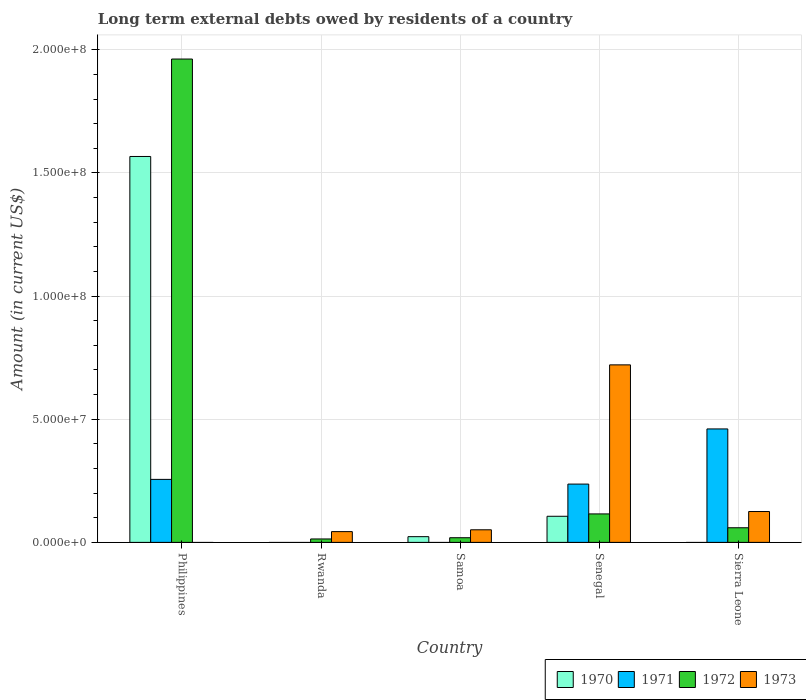How many different coloured bars are there?
Offer a very short reply. 4. Are the number of bars per tick equal to the number of legend labels?
Your answer should be very brief. No. How many bars are there on the 5th tick from the left?
Give a very brief answer. 3. What is the label of the 1st group of bars from the left?
Your response must be concise. Philippines. What is the amount of long-term external debts owed by residents in 1970 in Philippines?
Give a very brief answer. 1.57e+08. Across all countries, what is the maximum amount of long-term external debts owed by residents in 1973?
Provide a short and direct response. 7.21e+07. In which country was the amount of long-term external debts owed by residents in 1971 maximum?
Make the answer very short. Sierra Leone. What is the total amount of long-term external debts owed by residents in 1973 in the graph?
Make the answer very short. 9.41e+07. What is the difference between the amount of long-term external debts owed by residents in 1970 in Philippines and that in Samoa?
Ensure brevity in your answer.  1.54e+08. What is the difference between the amount of long-term external debts owed by residents in 1971 in Sierra Leone and the amount of long-term external debts owed by residents in 1973 in Rwanda?
Your response must be concise. 4.17e+07. What is the average amount of long-term external debts owed by residents in 1972 per country?
Provide a succinct answer. 4.34e+07. What is the difference between the amount of long-term external debts owed by residents of/in 1972 and amount of long-term external debts owed by residents of/in 1971 in Philippines?
Your answer should be very brief. 1.71e+08. In how many countries, is the amount of long-term external debts owed by residents in 1973 greater than 10000000 US$?
Make the answer very short. 2. What is the ratio of the amount of long-term external debts owed by residents in 1970 in Philippines to that in Senegal?
Offer a very short reply. 14.78. Is the amount of long-term external debts owed by residents in 1971 in Philippines less than that in Senegal?
Ensure brevity in your answer.  No. Is the difference between the amount of long-term external debts owed by residents in 1972 in Philippines and Senegal greater than the difference between the amount of long-term external debts owed by residents in 1971 in Philippines and Senegal?
Give a very brief answer. Yes. What is the difference between the highest and the second highest amount of long-term external debts owed by residents in 1972?
Offer a very short reply. 1.90e+08. What is the difference between the highest and the lowest amount of long-term external debts owed by residents in 1970?
Give a very brief answer. 1.57e+08. In how many countries, is the amount of long-term external debts owed by residents in 1970 greater than the average amount of long-term external debts owed by residents in 1970 taken over all countries?
Offer a terse response. 1. Is the sum of the amount of long-term external debts owed by residents in 1973 in Samoa and Sierra Leone greater than the maximum amount of long-term external debts owed by residents in 1970 across all countries?
Offer a terse response. No. Are the values on the major ticks of Y-axis written in scientific E-notation?
Make the answer very short. Yes. Where does the legend appear in the graph?
Provide a succinct answer. Bottom right. How many legend labels are there?
Keep it short and to the point. 4. How are the legend labels stacked?
Offer a very short reply. Horizontal. What is the title of the graph?
Provide a short and direct response. Long term external debts owed by residents of a country. Does "2013" appear as one of the legend labels in the graph?
Your response must be concise. No. What is the label or title of the X-axis?
Your answer should be compact. Country. What is the label or title of the Y-axis?
Provide a short and direct response. Amount (in current US$). What is the Amount (in current US$) of 1970 in Philippines?
Offer a very short reply. 1.57e+08. What is the Amount (in current US$) in 1971 in Philippines?
Offer a terse response. 2.56e+07. What is the Amount (in current US$) in 1972 in Philippines?
Ensure brevity in your answer.  1.96e+08. What is the Amount (in current US$) in 1972 in Rwanda?
Your response must be concise. 1.39e+06. What is the Amount (in current US$) in 1973 in Rwanda?
Your response must be concise. 4.37e+06. What is the Amount (in current US$) of 1970 in Samoa?
Your answer should be compact. 2.32e+06. What is the Amount (in current US$) in 1972 in Samoa?
Provide a succinct answer. 1.89e+06. What is the Amount (in current US$) of 1973 in Samoa?
Provide a succinct answer. 5.11e+06. What is the Amount (in current US$) in 1970 in Senegal?
Provide a succinct answer. 1.06e+07. What is the Amount (in current US$) in 1971 in Senegal?
Your answer should be very brief. 2.37e+07. What is the Amount (in current US$) in 1972 in Senegal?
Make the answer very short. 1.16e+07. What is the Amount (in current US$) of 1973 in Senegal?
Offer a terse response. 7.21e+07. What is the Amount (in current US$) of 1970 in Sierra Leone?
Provide a succinct answer. 0. What is the Amount (in current US$) of 1971 in Sierra Leone?
Your answer should be compact. 4.61e+07. What is the Amount (in current US$) of 1972 in Sierra Leone?
Offer a terse response. 5.94e+06. What is the Amount (in current US$) of 1973 in Sierra Leone?
Offer a terse response. 1.25e+07. Across all countries, what is the maximum Amount (in current US$) of 1970?
Your answer should be very brief. 1.57e+08. Across all countries, what is the maximum Amount (in current US$) in 1971?
Offer a very short reply. 4.61e+07. Across all countries, what is the maximum Amount (in current US$) in 1972?
Provide a short and direct response. 1.96e+08. Across all countries, what is the maximum Amount (in current US$) in 1973?
Your answer should be compact. 7.21e+07. Across all countries, what is the minimum Amount (in current US$) in 1970?
Ensure brevity in your answer.  0. Across all countries, what is the minimum Amount (in current US$) of 1972?
Make the answer very short. 1.39e+06. What is the total Amount (in current US$) of 1970 in the graph?
Offer a very short reply. 1.70e+08. What is the total Amount (in current US$) in 1971 in the graph?
Make the answer very short. 9.53e+07. What is the total Amount (in current US$) in 1972 in the graph?
Provide a succinct answer. 2.17e+08. What is the total Amount (in current US$) of 1973 in the graph?
Provide a short and direct response. 9.41e+07. What is the difference between the Amount (in current US$) in 1972 in Philippines and that in Rwanda?
Give a very brief answer. 1.95e+08. What is the difference between the Amount (in current US$) of 1970 in Philippines and that in Samoa?
Offer a very short reply. 1.54e+08. What is the difference between the Amount (in current US$) in 1972 in Philippines and that in Samoa?
Your answer should be compact. 1.94e+08. What is the difference between the Amount (in current US$) in 1970 in Philippines and that in Senegal?
Your answer should be very brief. 1.46e+08. What is the difference between the Amount (in current US$) of 1971 in Philippines and that in Senegal?
Your answer should be compact. 1.91e+06. What is the difference between the Amount (in current US$) of 1972 in Philippines and that in Senegal?
Make the answer very short. 1.85e+08. What is the difference between the Amount (in current US$) of 1971 in Philippines and that in Sierra Leone?
Ensure brevity in your answer.  -2.05e+07. What is the difference between the Amount (in current US$) in 1972 in Philippines and that in Sierra Leone?
Provide a succinct answer. 1.90e+08. What is the difference between the Amount (in current US$) in 1972 in Rwanda and that in Samoa?
Offer a terse response. -5.01e+05. What is the difference between the Amount (in current US$) of 1973 in Rwanda and that in Samoa?
Offer a terse response. -7.38e+05. What is the difference between the Amount (in current US$) of 1972 in Rwanda and that in Senegal?
Your response must be concise. -1.02e+07. What is the difference between the Amount (in current US$) in 1973 in Rwanda and that in Senegal?
Your answer should be very brief. -6.77e+07. What is the difference between the Amount (in current US$) in 1972 in Rwanda and that in Sierra Leone?
Your answer should be compact. -4.55e+06. What is the difference between the Amount (in current US$) in 1973 in Rwanda and that in Sierra Leone?
Provide a short and direct response. -8.16e+06. What is the difference between the Amount (in current US$) in 1970 in Samoa and that in Senegal?
Keep it short and to the point. -8.28e+06. What is the difference between the Amount (in current US$) of 1972 in Samoa and that in Senegal?
Ensure brevity in your answer.  -9.67e+06. What is the difference between the Amount (in current US$) of 1973 in Samoa and that in Senegal?
Your response must be concise. -6.70e+07. What is the difference between the Amount (in current US$) of 1972 in Samoa and that in Sierra Leone?
Your response must be concise. -4.05e+06. What is the difference between the Amount (in current US$) of 1973 in Samoa and that in Sierra Leone?
Your answer should be very brief. -7.42e+06. What is the difference between the Amount (in current US$) of 1971 in Senegal and that in Sierra Leone?
Keep it short and to the point. -2.24e+07. What is the difference between the Amount (in current US$) of 1972 in Senegal and that in Sierra Leone?
Offer a very short reply. 5.62e+06. What is the difference between the Amount (in current US$) of 1973 in Senegal and that in Sierra Leone?
Give a very brief answer. 5.95e+07. What is the difference between the Amount (in current US$) of 1970 in Philippines and the Amount (in current US$) of 1972 in Rwanda?
Keep it short and to the point. 1.55e+08. What is the difference between the Amount (in current US$) in 1970 in Philippines and the Amount (in current US$) in 1973 in Rwanda?
Offer a very short reply. 1.52e+08. What is the difference between the Amount (in current US$) in 1971 in Philippines and the Amount (in current US$) in 1972 in Rwanda?
Give a very brief answer. 2.42e+07. What is the difference between the Amount (in current US$) in 1971 in Philippines and the Amount (in current US$) in 1973 in Rwanda?
Your answer should be very brief. 2.12e+07. What is the difference between the Amount (in current US$) of 1972 in Philippines and the Amount (in current US$) of 1973 in Rwanda?
Keep it short and to the point. 1.92e+08. What is the difference between the Amount (in current US$) in 1970 in Philippines and the Amount (in current US$) in 1972 in Samoa?
Make the answer very short. 1.55e+08. What is the difference between the Amount (in current US$) of 1970 in Philippines and the Amount (in current US$) of 1973 in Samoa?
Give a very brief answer. 1.52e+08. What is the difference between the Amount (in current US$) of 1971 in Philippines and the Amount (in current US$) of 1972 in Samoa?
Your answer should be compact. 2.37e+07. What is the difference between the Amount (in current US$) in 1971 in Philippines and the Amount (in current US$) in 1973 in Samoa?
Make the answer very short. 2.05e+07. What is the difference between the Amount (in current US$) of 1972 in Philippines and the Amount (in current US$) of 1973 in Samoa?
Offer a terse response. 1.91e+08. What is the difference between the Amount (in current US$) of 1970 in Philippines and the Amount (in current US$) of 1971 in Senegal?
Your response must be concise. 1.33e+08. What is the difference between the Amount (in current US$) in 1970 in Philippines and the Amount (in current US$) in 1972 in Senegal?
Give a very brief answer. 1.45e+08. What is the difference between the Amount (in current US$) in 1970 in Philippines and the Amount (in current US$) in 1973 in Senegal?
Offer a terse response. 8.46e+07. What is the difference between the Amount (in current US$) of 1971 in Philippines and the Amount (in current US$) of 1972 in Senegal?
Give a very brief answer. 1.40e+07. What is the difference between the Amount (in current US$) in 1971 in Philippines and the Amount (in current US$) in 1973 in Senegal?
Your answer should be compact. -4.65e+07. What is the difference between the Amount (in current US$) in 1972 in Philippines and the Amount (in current US$) in 1973 in Senegal?
Your answer should be compact. 1.24e+08. What is the difference between the Amount (in current US$) of 1970 in Philippines and the Amount (in current US$) of 1971 in Sierra Leone?
Offer a very short reply. 1.11e+08. What is the difference between the Amount (in current US$) of 1970 in Philippines and the Amount (in current US$) of 1972 in Sierra Leone?
Give a very brief answer. 1.51e+08. What is the difference between the Amount (in current US$) of 1970 in Philippines and the Amount (in current US$) of 1973 in Sierra Leone?
Keep it short and to the point. 1.44e+08. What is the difference between the Amount (in current US$) of 1971 in Philippines and the Amount (in current US$) of 1972 in Sierra Leone?
Provide a succinct answer. 1.96e+07. What is the difference between the Amount (in current US$) in 1971 in Philippines and the Amount (in current US$) in 1973 in Sierra Leone?
Make the answer very short. 1.30e+07. What is the difference between the Amount (in current US$) of 1972 in Philippines and the Amount (in current US$) of 1973 in Sierra Leone?
Offer a terse response. 1.84e+08. What is the difference between the Amount (in current US$) in 1972 in Rwanda and the Amount (in current US$) in 1973 in Samoa?
Offer a very short reply. -3.72e+06. What is the difference between the Amount (in current US$) in 1972 in Rwanda and the Amount (in current US$) in 1973 in Senegal?
Provide a short and direct response. -7.07e+07. What is the difference between the Amount (in current US$) of 1972 in Rwanda and the Amount (in current US$) of 1973 in Sierra Leone?
Your answer should be compact. -1.11e+07. What is the difference between the Amount (in current US$) in 1970 in Samoa and the Amount (in current US$) in 1971 in Senegal?
Provide a succinct answer. -2.13e+07. What is the difference between the Amount (in current US$) in 1970 in Samoa and the Amount (in current US$) in 1972 in Senegal?
Your response must be concise. -9.23e+06. What is the difference between the Amount (in current US$) of 1970 in Samoa and the Amount (in current US$) of 1973 in Senegal?
Give a very brief answer. -6.98e+07. What is the difference between the Amount (in current US$) of 1972 in Samoa and the Amount (in current US$) of 1973 in Senegal?
Make the answer very short. -7.02e+07. What is the difference between the Amount (in current US$) in 1970 in Samoa and the Amount (in current US$) in 1971 in Sierra Leone?
Provide a short and direct response. -4.37e+07. What is the difference between the Amount (in current US$) of 1970 in Samoa and the Amount (in current US$) of 1972 in Sierra Leone?
Your answer should be very brief. -3.61e+06. What is the difference between the Amount (in current US$) in 1970 in Samoa and the Amount (in current US$) in 1973 in Sierra Leone?
Make the answer very short. -1.02e+07. What is the difference between the Amount (in current US$) of 1972 in Samoa and the Amount (in current US$) of 1973 in Sierra Leone?
Give a very brief answer. -1.06e+07. What is the difference between the Amount (in current US$) of 1970 in Senegal and the Amount (in current US$) of 1971 in Sierra Leone?
Offer a terse response. -3.55e+07. What is the difference between the Amount (in current US$) of 1970 in Senegal and the Amount (in current US$) of 1972 in Sierra Leone?
Keep it short and to the point. 4.66e+06. What is the difference between the Amount (in current US$) in 1970 in Senegal and the Amount (in current US$) in 1973 in Sierra Leone?
Offer a very short reply. -1.93e+06. What is the difference between the Amount (in current US$) of 1971 in Senegal and the Amount (in current US$) of 1972 in Sierra Leone?
Your response must be concise. 1.77e+07. What is the difference between the Amount (in current US$) of 1971 in Senegal and the Amount (in current US$) of 1973 in Sierra Leone?
Make the answer very short. 1.11e+07. What is the difference between the Amount (in current US$) of 1972 in Senegal and the Amount (in current US$) of 1973 in Sierra Leone?
Your answer should be compact. -9.76e+05. What is the average Amount (in current US$) in 1970 per country?
Your answer should be compact. 3.39e+07. What is the average Amount (in current US$) of 1971 per country?
Give a very brief answer. 1.91e+07. What is the average Amount (in current US$) in 1972 per country?
Ensure brevity in your answer.  4.34e+07. What is the average Amount (in current US$) in 1973 per country?
Provide a succinct answer. 1.88e+07. What is the difference between the Amount (in current US$) in 1970 and Amount (in current US$) in 1971 in Philippines?
Keep it short and to the point. 1.31e+08. What is the difference between the Amount (in current US$) of 1970 and Amount (in current US$) of 1972 in Philippines?
Your answer should be compact. -3.96e+07. What is the difference between the Amount (in current US$) in 1971 and Amount (in current US$) in 1972 in Philippines?
Make the answer very short. -1.71e+08. What is the difference between the Amount (in current US$) in 1972 and Amount (in current US$) in 1973 in Rwanda?
Keep it short and to the point. -2.98e+06. What is the difference between the Amount (in current US$) in 1970 and Amount (in current US$) in 1972 in Samoa?
Ensure brevity in your answer.  4.36e+05. What is the difference between the Amount (in current US$) in 1970 and Amount (in current US$) in 1973 in Samoa?
Your answer should be compact. -2.79e+06. What is the difference between the Amount (in current US$) in 1972 and Amount (in current US$) in 1973 in Samoa?
Make the answer very short. -3.22e+06. What is the difference between the Amount (in current US$) in 1970 and Amount (in current US$) in 1971 in Senegal?
Make the answer very short. -1.31e+07. What is the difference between the Amount (in current US$) in 1970 and Amount (in current US$) in 1972 in Senegal?
Ensure brevity in your answer.  -9.56e+05. What is the difference between the Amount (in current US$) in 1970 and Amount (in current US$) in 1973 in Senegal?
Give a very brief answer. -6.15e+07. What is the difference between the Amount (in current US$) of 1971 and Amount (in current US$) of 1972 in Senegal?
Your answer should be compact. 1.21e+07. What is the difference between the Amount (in current US$) of 1971 and Amount (in current US$) of 1973 in Senegal?
Keep it short and to the point. -4.84e+07. What is the difference between the Amount (in current US$) of 1972 and Amount (in current US$) of 1973 in Senegal?
Your answer should be very brief. -6.05e+07. What is the difference between the Amount (in current US$) of 1971 and Amount (in current US$) of 1972 in Sierra Leone?
Ensure brevity in your answer.  4.01e+07. What is the difference between the Amount (in current US$) of 1971 and Amount (in current US$) of 1973 in Sierra Leone?
Give a very brief answer. 3.35e+07. What is the difference between the Amount (in current US$) in 1972 and Amount (in current US$) in 1973 in Sierra Leone?
Offer a terse response. -6.60e+06. What is the ratio of the Amount (in current US$) of 1972 in Philippines to that in Rwanda?
Provide a short and direct response. 141.39. What is the ratio of the Amount (in current US$) in 1970 in Philippines to that in Samoa?
Ensure brevity in your answer.  67.39. What is the ratio of the Amount (in current US$) of 1972 in Philippines to that in Samoa?
Offer a terse response. 103.89. What is the ratio of the Amount (in current US$) in 1970 in Philippines to that in Senegal?
Ensure brevity in your answer.  14.78. What is the ratio of the Amount (in current US$) in 1971 in Philippines to that in Senegal?
Ensure brevity in your answer.  1.08. What is the ratio of the Amount (in current US$) in 1972 in Philippines to that in Senegal?
Ensure brevity in your answer.  16.98. What is the ratio of the Amount (in current US$) in 1971 in Philippines to that in Sierra Leone?
Offer a very short reply. 0.56. What is the ratio of the Amount (in current US$) in 1972 in Philippines to that in Sierra Leone?
Your answer should be compact. 33.06. What is the ratio of the Amount (in current US$) in 1972 in Rwanda to that in Samoa?
Ensure brevity in your answer.  0.73. What is the ratio of the Amount (in current US$) in 1973 in Rwanda to that in Samoa?
Provide a short and direct response. 0.86. What is the ratio of the Amount (in current US$) of 1972 in Rwanda to that in Senegal?
Give a very brief answer. 0.12. What is the ratio of the Amount (in current US$) of 1973 in Rwanda to that in Senegal?
Your response must be concise. 0.06. What is the ratio of the Amount (in current US$) of 1972 in Rwanda to that in Sierra Leone?
Offer a very short reply. 0.23. What is the ratio of the Amount (in current US$) in 1973 in Rwanda to that in Sierra Leone?
Give a very brief answer. 0.35. What is the ratio of the Amount (in current US$) in 1970 in Samoa to that in Senegal?
Offer a very short reply. 0.22. What is the ratio of the Amount (in current US$) in 1972 in Samoa to that in Senegal?
Your answer should be compact. 0.16. What is the ratio of the Amount (in current US$) in 1973 in Samoa to that in Senegal?
Offer a terse response. 0.07. What is the ratio of the Amount (in current US$) in 1972 in Samoa to that in Sierra Leone?
Provide a succinct answer. 0.32. What is the ratio of the Amount (in current US$) in 1973 in Samoa to that in Sierra Leone?
Offer a very short reply. 0.41. What is the ratio of the Amount (in current US$) in 1971 in Senegal to that in Sierra Leone?
Your answer should be very brief. 0.51. What is the ratio of the Amount (in current US$) of 1972 in Senegal to that in Sierra Leone?
Provide a succinct answer. 1.95. What is the ratio of the Amount (in current US$) of 1973 in Senegal to that in Sierra Leone?
Give a very brief answer. 5.75. What is the difference between the highest and the second highest Amount (in current US$) of 1970?
Provide a short and direct response. 1.46e+08. What is the difference between the highest and the second highest Amount (in current US$) of 1971?
Provide a succinct answer. 2.05e+07. What is the difference between the highest and the second highest Amount (in current US$) of 1972?
Ensure brevity in your answer.  1.85e+08. What is the difference between the highest and the second highest Amount (in current US$) of 1973?
Provide a short and direct response. 5.95e+07. What is the difference between the highest and the lowest Amount (in current US$) in 1970?
Ensure brevity in your answer.  1.57e+08. What is the difference between the highest and the lowest Amount (in current US$) of 1971?
Offer a terse response. 4.61e+07. What is the difference between the highest and the lowest Amount (in current US$) in 1972?
Offer a very short reply. 1.95e+08. What is the difference between the highest and the lowest Amount (in current US$) in 1973?
Provide a short and direct response. 7.21e+07. 